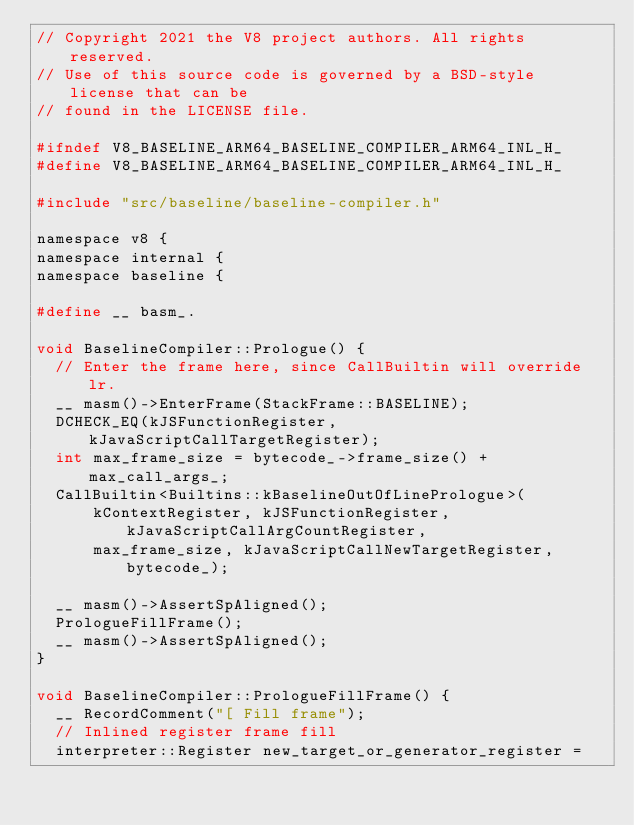Convert code to text. <code><loc_0><loc_0><loc_500><loc_500><_C_>// Copyright 2021 the V8 project authors. All rights reserved.
// Use of this source code is governed by a BSD-style license that can be
// found in the LICENSE file.

#ifndef V8_BASELINE_ARM64_BASELINE_COMPILER_ARM64_INL_H_
#define V8_BASELINE_ARM64_BASELINE_COMPILER_ARM64_INL_H_

#include "src/baseline/baseline-compiler.h"

namespace v8 {
namespace internal {
namespace baseline {

#define __ basm_.

void BaselineCompiler::Prologue() {
  // Enter the frame here, since CallBuiltin will override lr.
  __ masm()->EnterFrame(StackFrame::BASELINE);
  DCHECK_EQ(kJSFunctionRegister, kJavaScriptCallTargetRegister);
  int max_frame_size = bytecode_->frame_size() + max_call_args_;
  CallBuiltin<Builtins::kBaselineOutOfLinePrologue>(
      kContextRegister, kJSFunctionRegister, kJavaScriptCallArgCountRegister,
      max_frame_size, kJavaScriptCallNewTargetRegister, bytecode_);

  __ masm()->AssertSpAligned();
  PrologueFillFrame();
  __ masm()->AssertSpAligned();
}

void BaselineCompiler::PrologueFillFrame() {
  __ RecordComment("[ Fill frame");
  // Inlined register frame fill
  interpreter::Register new_target_or_generator_register =</code> 